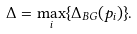<formula> <loc_0><loc_0><loc_500><loc_500>\Delta = \max _ { i } \{ \Delta _ { B G } { \left ( p _ { i } \right ) } \} .</formula> 